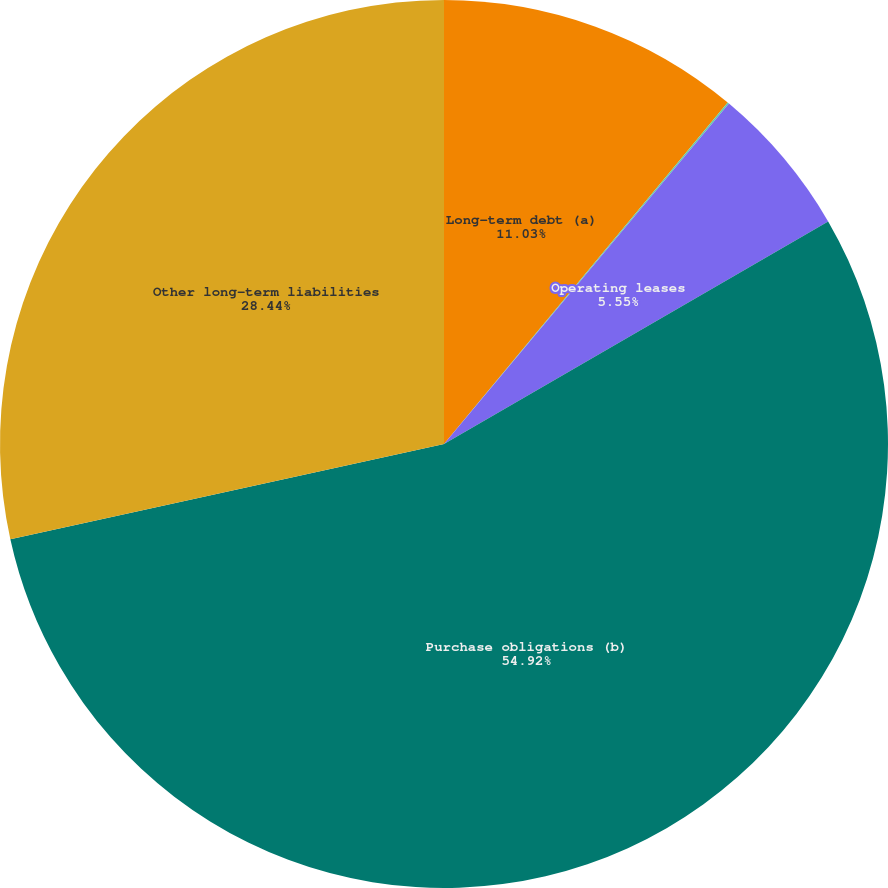Convert chart to OTSL. <chart><loc_0><loc_0><loc_500><loc_500><pie_chart><fcel>Long-term debt (a)<fcel>Capital lease obligations<fcel>Operating leases<fcel>Purchase obligations (b)<fcel>Other long-term liabilities<nl><fcel>11.03%<fcel>0.06%<fcel>5.55%<fcel>54.91%<fcel>28.44%<nl></chart> 